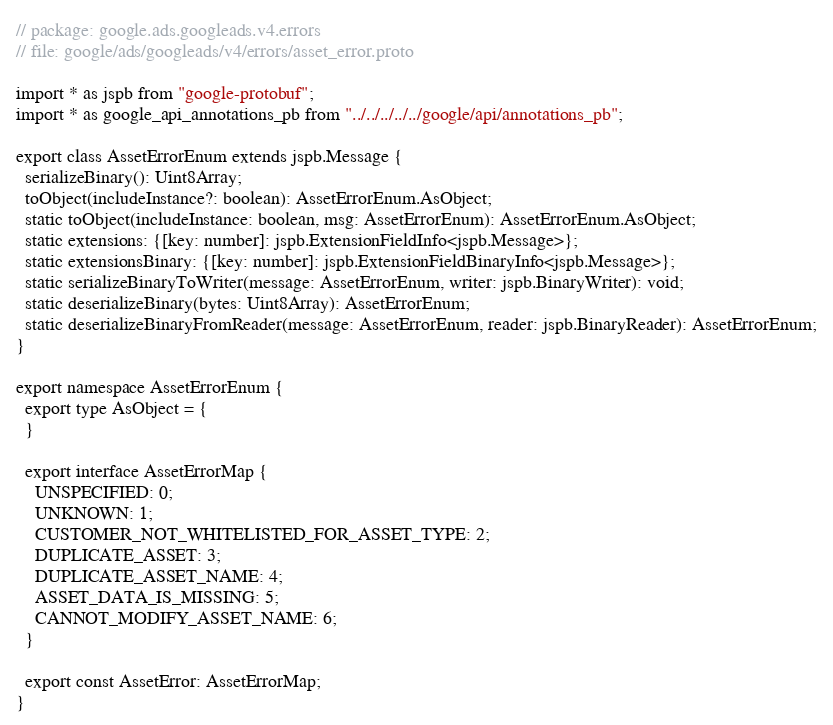<code> <loc_0><loc_0><loc_500><loc_500><_TypeScript_>// package: google.ads.googleads.v4.errors
// file: google/ads/googleads/v4/errors/asset_error.proto

import * as jspb from "google-protobuf";
import * as google_api_annotations_pb from "../../../../../google/api/annotations_pb";

export class AssetErrorEnum extends jspb.Message {
  serializeBinary(): Uint8Array;
  toObject(includeInstance?: boolean): AssetErrorEnum.AsObject;
  static toObject(includeInstance: boolean, msg: AssetErrorEnum): AssetErrorEnum.AsObject;
  static extensions: {[key: number]: jspb.ExtensionFieldInfo<jspb.Message>};
  static extensionsBinary: {[key: number]: jspb.ExtensionFieldBinaryInfo<jspb.Message>};
  static serializeBinaryToWriter(message: AssetErrorEnum, writer: jspb.BinaryWriter): void;
  static deserializeBinary(bytes: Uint8Array): AssetErrorEnum;
  static deserializeBinaryFromReader(message: AssetErrorEnum, reader: jspb.BinaryReader): AssetErrorEnum;
}

export namespace AssetErrorEnum {
  export type AsObject = {
  }

  export interface AssetErrorMap {
    UNSPECIFIED: 0;
    UNKNOWN: 1;
    CUSTOMER_NOT_WHITELISTED_FOR_ASSET_TYPE: 2;
    DUPLICATE_ASSET: 3;
    DUPLICATE_ASSET_NAME: 4;
    ASSET_DATA_IS_MISSING: 5;
    CANNOT_MODIFY_ASSET_NAME: 6;
  }

  export const AssetError: AssetErrorMap;
}

</code> 